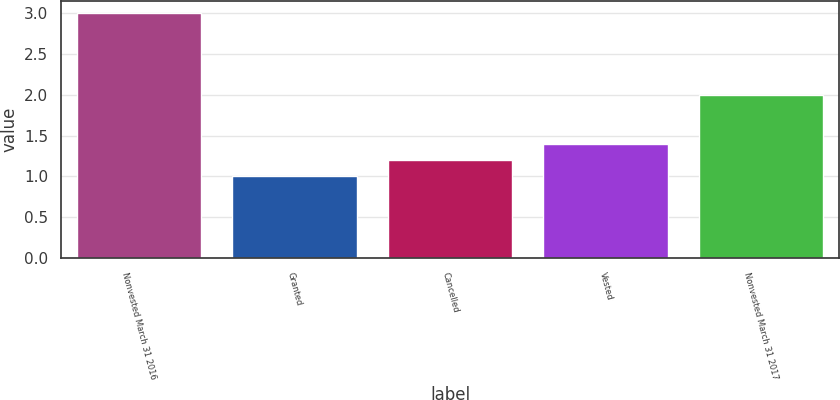Convert chart. <chart><loc_0><loc_0><loc_500><loc_500><bar_chart><fcel>Nonvested March 31 2016<fcel>Granted<fcel>Cancelled<fcel>Vested<fcel>Nonvested March 31 2017<nl><fcel>3<fcel>1<fcel>1.2<fcel>1.4<fcel>2<nl></chart> 